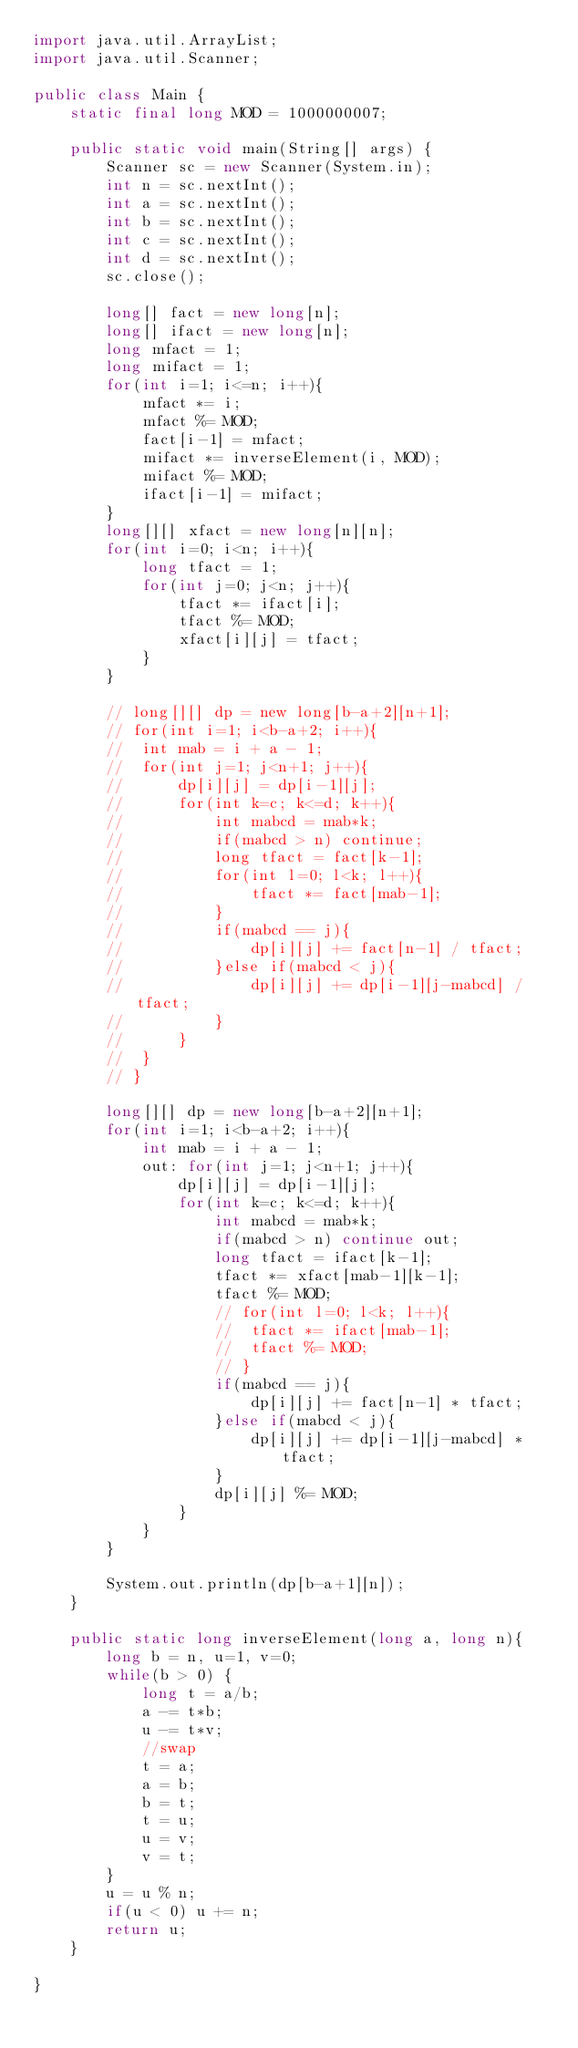<code> <loc_0><loc_0><loc_500><loc_500><_Java_>import java.util.ArrayList;
import java.util.Scanner;

public class Main {
	static final long MOD = 1000000007;

	public static void main(String[] args) {
		Scanner sc = new Scanner(System.in);
		int n = sc.nextInt();
		int a = sc.nextInt();
		int b = sc.nextInt();
		int c = sc.nextInt();
		int d = sc.nextInt();
		sc.close();

		long[] fact = new long[n];
		long[] ifact = new long[n];
		long mfact = 1;
		long mifact = 1;
		for(int i=1; i<=n; i++){
			mfact *= i;
			mfact %= MOD;
			fact[i-1] = mfact;
			mifact *= inverseElement(i, MOD);
			mifact %= MOD;
			ifact[i-1] = mifact;
		}
		long[][] xfact = new long[n][n];
		for(int i=0; i<n; i++){
			long tfact = 1;
			for(int j=0; j<n; j++){
				tfact *= ifact[i];
				tfact %= MOD;
				xfact[i][j] = tfact;
			}
		}

		// long[][] dp = new long[b-a+2][n+1];
		// for(int i=1; i<b-a+2; i++){
		// 	int mab = i + a - 1;
		// 	for(int j=1; j<n+1; j++){
		// 		dp[i][j] = dp[i-1][j];
		// 		for(int k=c; k<=d; k++){
		// 			int mabcd = mab*k;
		// 			if(mabcd > n) continue;
		// 			long tfact = fact[k-1];
		// 			for(int l=0; l<k; l++){
		// 				tfact *= fact[mab-1];
		// 			}
		// 			if(mabcd == j){
		// 				dp[i][j] += fact[n-1] / tfact;
		// 			}else if(mabcd < j){
		// 				dp[i][j] += dp[i-1][j-mabcd] / tfact;
		// 			}
		// 		}
		// 	}
		// }
		
		long[][] dp = new long[b-a+2][n+1];
		for(int i=1; i<b-a+2; i++){
			int mab = i + a - 1;
			out: for(int j=1; j<n+1; j++){
				dp[i][j] = dp[i-1][j];
				for(int k=c; k<=d; k++){
					int mabcd = mab*k;
					if(mabcd > n) continue out;
					long tfact = ifact[k-1];
					tfact *= xfact[mab-1][k-1];
					tfact %= MOD;
					// for(int l=0; l<k; l++){
					// 	tfact *= ifact[mab-1];
					// 	tfact %= MOD;
					// }
					if(mabcd == j){
						dp[i][j] += fact[n-1] * tfact;
					}else if(mabcd < j){
						dp[i][j] += dp[i-1][j-mabcd] * tfact;
					}
					dp[i][j] %= MOD;
				}
			}
		}

		System.out.println(dp[b-a+1][n]);
	}

	public static long inverseElement(long a, long n){
        long b = n, u=1, v=0;
        while(b > 0) {
            long t = a/b;
            a -= t*b;
            u -= t*v;
            //swap
            t = a;
            a = b;
            b = t;
            t = u;
            u = v;
            v = t;
        }
        u = u % n;
        if(u < 0) u += n;
        return u;
    }

}
</code> 